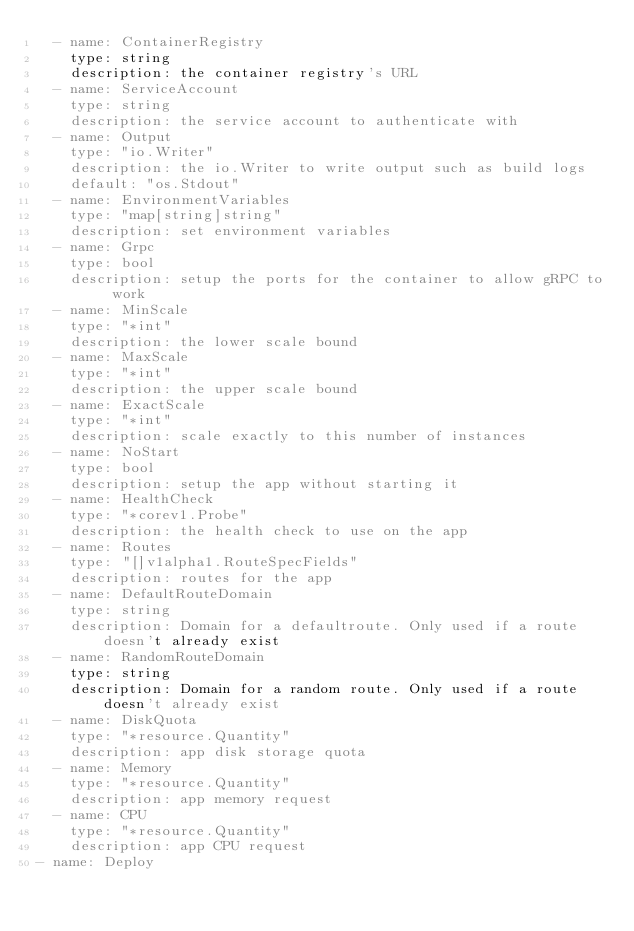Convert code to text. <code><loc_0><loc_0><loc_500><loc_500><_YAML_>  - name: ContainerRegistry
    type: string
    description: the container registry's URL
  - name: ServiceAccount
    type: string
    description: the service account to authenticate with
  - name: Output
    type: "io.Writer"
    description: the io.Writer to write output such as build logs
    default: "os.Stdout"
  - name: EnvironmentVariables
    type: "map[string]string"
    description: set environment variables
  - name: Grpc
    type: bool
    description: setup the ports for the container to allow gRPC to work
  - name: MinScale
    type: "*int"
    description: the lower scale bound
  - name: MaxScale
    type: "*int"
    description: the upper scale bound
  - name: ExactScale
    type: "*int"
    description: scale exactly to this number of instances
  - name: NoStart
    type: bool
    description: setup the app without starting it
  - name: HealthCheck
    type: "*corev1.Probe"
    description: the health check to use on the app
  - name: Routes
    type: "[]v1alpha1.RouteSpecFields"
    description: routes for the app
  - name: DefaultRouteDomain
    type: string
    description: Domain for a defaultroute. Only used if a route doesn't already exist
  - name: RandomRouteDomain
    type: string
    description: Domain for a random route. Only used if a route doesn't already exist
  - name: DiskQuota
    type: "*resource.Quantity"
    description: app disk storage quota
  - name: Memory
    type: "*resource.Quantity"
    description: app memory request
  - name: CPU
    type: "*resource.Quantity"
    description: app CPU request
- name: Deploy
</code> 